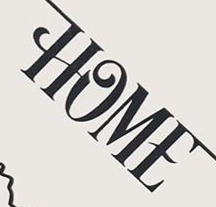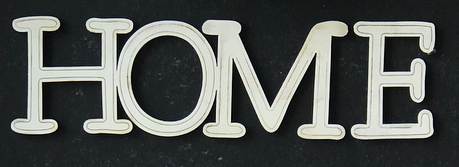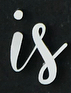What text appears in these images from left to right, separated by a semicolon? HOME; HOME; is 